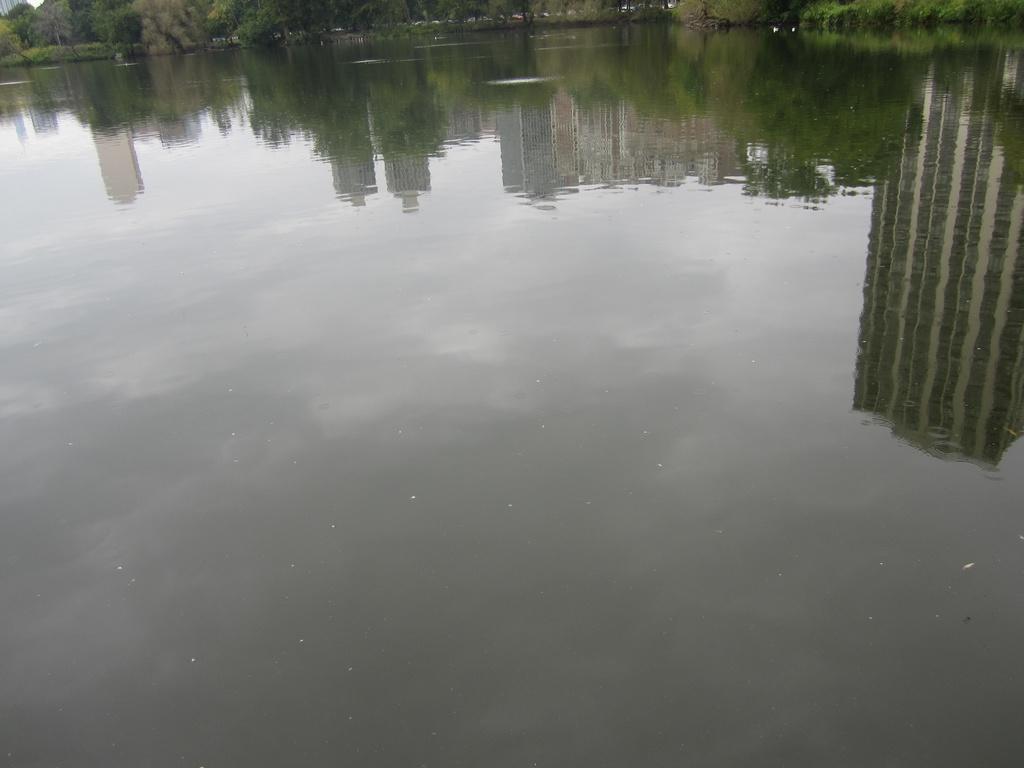Please provide a concise description of this image. In this picture we can see the lake on which I can see the reflection of some trees, buildings. 